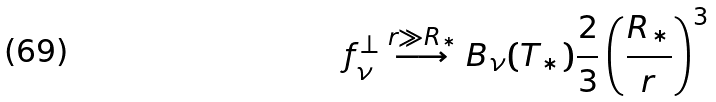<formula> <loc_0><loc_0><loc_500><loc_500>f ^ { \perp } _ { \nu } \stackrel { r \gg R _ { * } } { \longrightarrow } B _ { \nu } ( T _ { * } ) \frac { 2 } { 3 } \left ( \frac { R _ { * } } { r } \right ) ^ { 3 }</formula> 